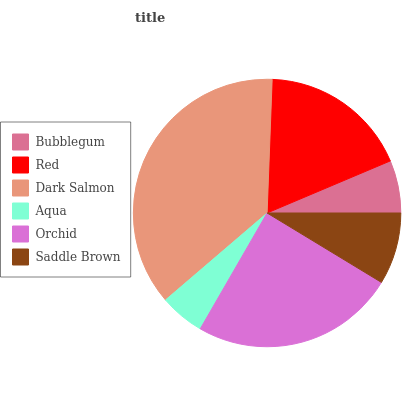Is Aqua the minimum?
Answer yes or no. Yes. Is Dark Salmon the maximum?
Answer yes or no. Yes. Is Red the minimum?
Answer yes or no. No. Is Red the maximum?
Answer yes or no. No. Is Red greater than Bubblegum?
Answer yes or no. Yes. Is Bubblegum less than Red?
Answer yes or no. Yes. Is Bubblegum greater than Red?
Answer yes or no. No. Is Red less than Bubblegum?
Answer yes or no. No. Is Red the high median?
Answer yes or no. Yes. Is Saddle Brown the low median?
Answer yes or no. Yes. Is Orchid the high median?
Answer yes or no. No. Is Red the low median?
Answer yes or no. No. 